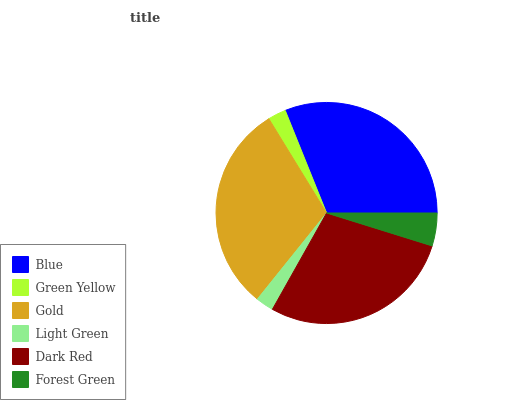Is Light Green the minimum?
Answer yes or no. Yes. Is Blue the maximum?
Answer yes or no. Yes. Is Green Yellow the minimum?
Answer yes or no. No. Is Green Yellow the maximum?
Answer yes or no. No. Is Blue greater than Green Yellow?
Answer yes or no. Yes. Is Green Yellow less than Blue?
Answer yes or no. Yes. Is Green Yellow greater than Blue?
Answer yes or no. No. Is Blue less than Green Yellow?
Answer yes or no. No. Is Dark Red the high median?
Answer yes or no. Yes. Is Forest Green the low median?
Answer yes or no. Yes. Is Gold the high median?
Answer yes or no. No. Is Gold the low median?
Answer yes or no. No. 